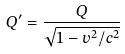Convert formula to latex. <formula><loc_0><loc_0><loc_500><loc_500>Q ^ { \prime } = \frac { Q } { \sqrt { 1 - v ^ { 2 } / c ^ { 2 } } }</formula> 